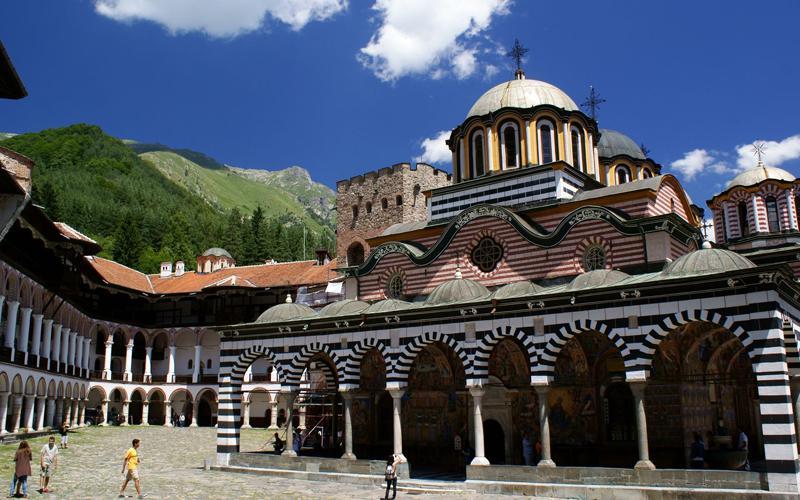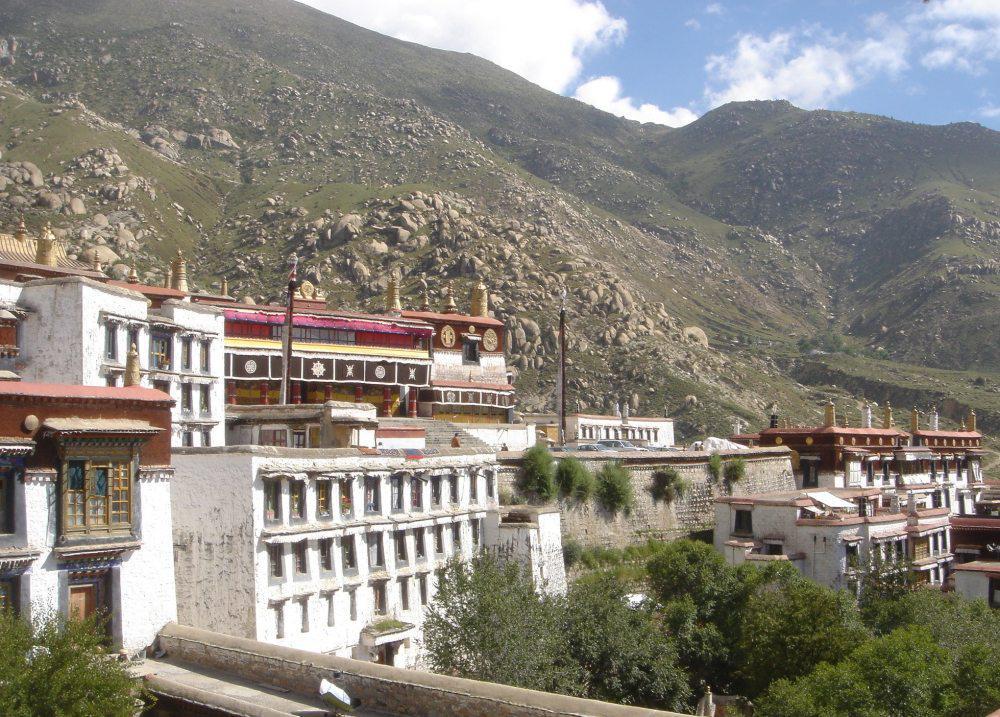The first image is the image on the left, the second image is the image on the right. For the images displayed, is the sentence "In at least one image there is a squared white walled building with at least three floors." factually correct? Answer yes or no. Yes. 